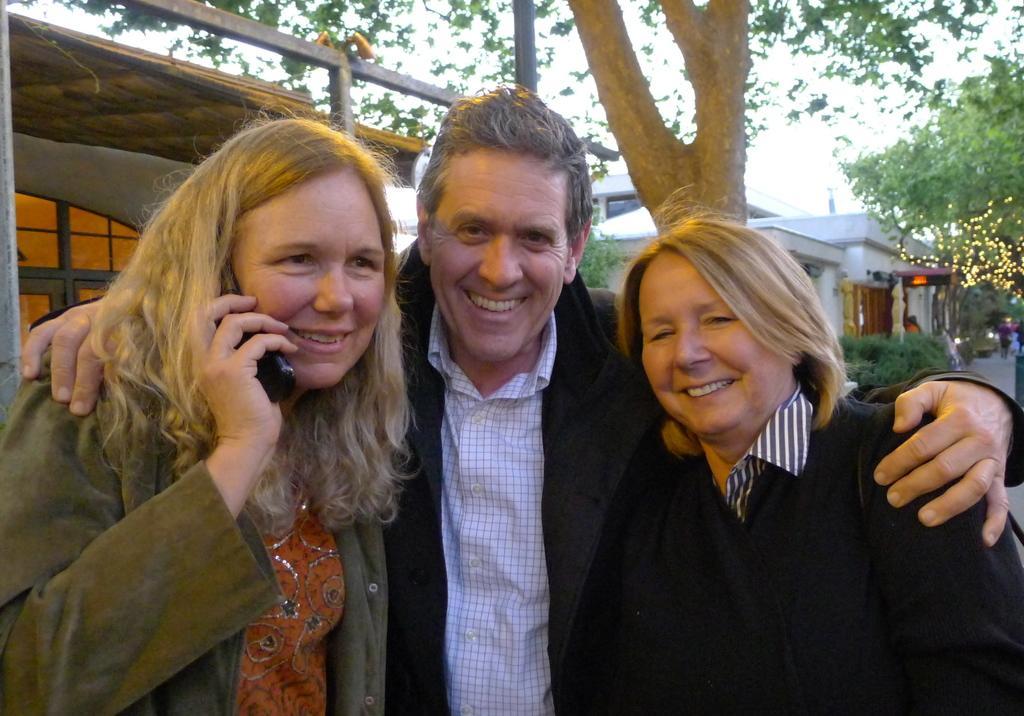Please provide a concise description of this image. In this image there is a metal object and there is a window on the left corner. There are people in the foreground. There are trees on the right corner. There is a building, there are trees and people in the background. And there is sky at the top. 